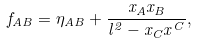Convert formula to latex. <formula><loc_0><loc_0><loc_500><loc_500>f _ { A B } = \eta _ { A B } + \frac { x _ { A } x _ { B } } { l ^ { 2 } - x _ { C } x ^ { C } } ,</formula> 